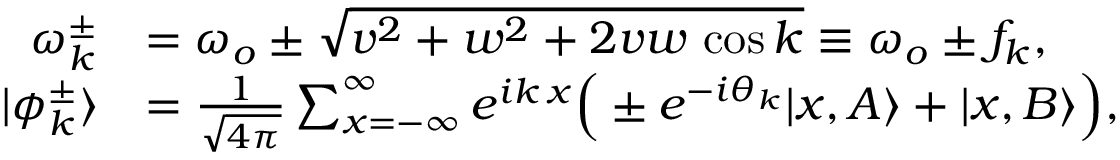<formula> <loc_0><loc_0><loc_500><loc_500>\begin{array} { r l } { \omega _ { k } ^ { \pm } } & { = \omega _ { o } \pm \sqrt { v ^ { 2 } + w ^ { 2 } + 2 v w \, \cos { k } } \equiv \omega _ { o } \pm f _ { k } , } \\ { | \phi _ { k } ^ { \pm } \rangle } & { = \frac { 1 } { \sqrt { 4 \pi } } \sum _ { x = - \infty } ^ { \infty } e ^ { i k \, x } \left ( \pm e ^ { - i \theta _ { k } } | x , A \rangle + | x , B \rangle \right ) , } \end{array}</formula> 